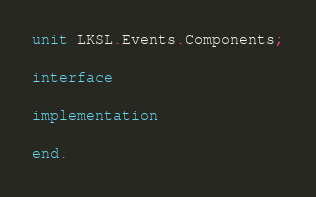<code> <loc_0><loc_0><loc_500><loc_500><_Pascal_>unit LKSL.Events.Components;

interface

implementation

end.
</code> 